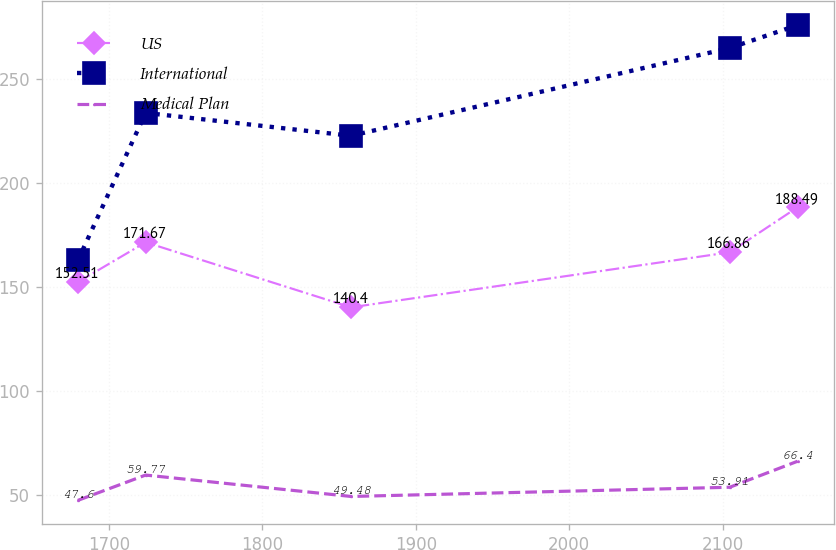Convert chart to OTSL. <chart><loc_0><loc_0><loc_500><loc_500><line_chart><ecel><fcel>US<fcel>International<fcel>Medical Plan<nl><fcel>1679.83<fcel>152.51<fcel>162.95<fcel>47.6<nl><fcel>1724<fcel>171.67<fcel>233.87<fcel>59.77<nl><fcel>1857.89<fcel>140.4<fcel>222.87<fcel>49.48<nl><fcel>2104.65<fcel>166.86<fcel>265.05<fcel>53.91<nl><fcel>2148.83<fcel>188.49<fcel>276.05<fcel>66.4<nl></chart> 